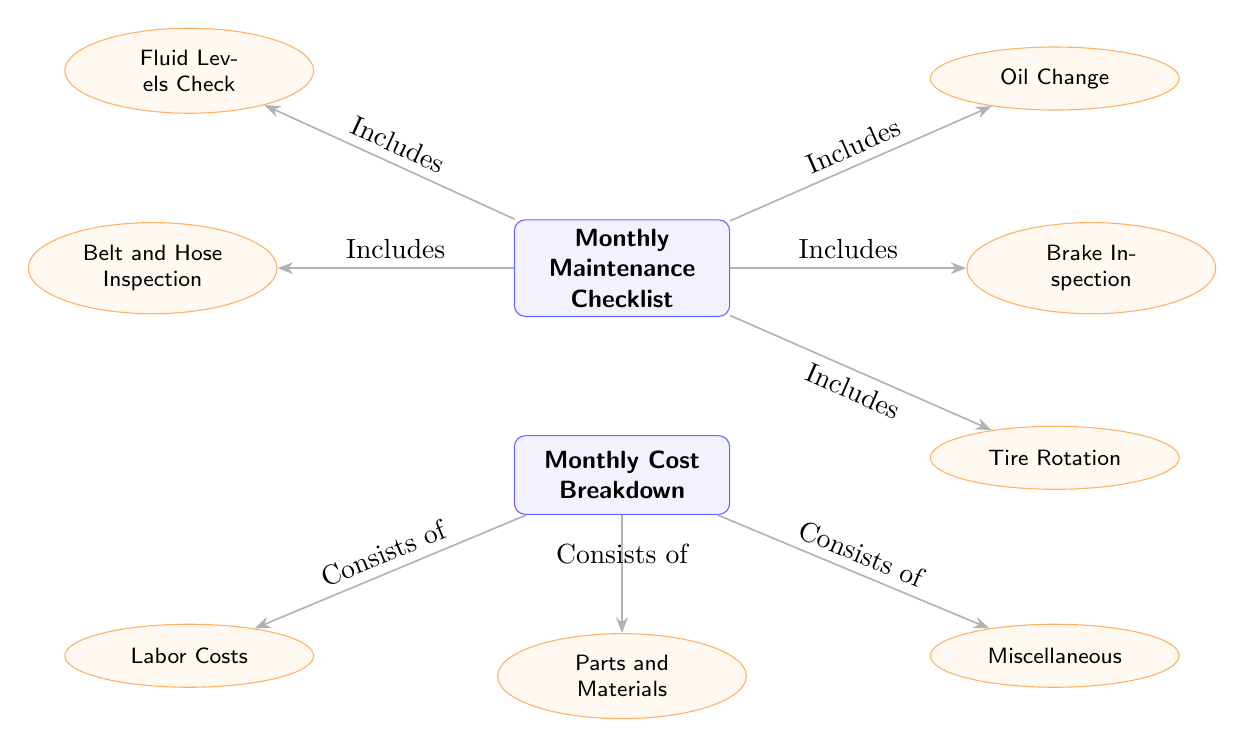What are the items included in the Monthly Maintenance Checklist? The Monthly Maintenance Checklist node connects to five subnodes: Oil Change, Brake Inspection, Tire Rotation, Fluid Levels Check, and Belt and Hose Inspection. Each of these items is listed under the checklist.
Answer: Oil Change, Brake Inspection, Tire Rotation, Fluid Levels Check, Belt and Hose Inspection How many subnodes does the Monthly Cost Breakdown have? The Monthly Cost Breakdown node has three subnodes: Labor Costs, Parts and Materials, and Miscellaneous. Counting them gives us a total of three subnodes.
Answer: 3 What is the relationship between the Monthly Maintenance Checklist and Oil Change? The Monthly Maintenance Checklist node is directly connected to the Oil Change subnode with an edge labeled "Includes." This indicates that Oil Change is part of the checklist.
Answer: Includes What are the costs that the Monthly Cost Breakdown consists of? The Monthly Cost Breakdown node has three connected subnodes: Labor Costs, Parts and Materials, and Miscellaneous. Each of these items indicates components of the cost breakdown.
Answer: Labor Costs, Parts and Materials, Miscellaneous How many items are included in the checklist? The checklist connects to five subnodes (Oil Change, Brake Inspection, Tire Rotation, Fluid Levels Check, and Belt and Hose Inspection). Counting these gives us the total number of items.
Answer: 5 What helps explain the structure of the checklist and cost breakdown? The diagram's arrows indicate the connections between the main nodes and their subnodes, where "Includes" shows the relationship between the checklist items and the main checklist, while "Consists of" connects the cost breakdown to its respective components.
Answer: Arrows 